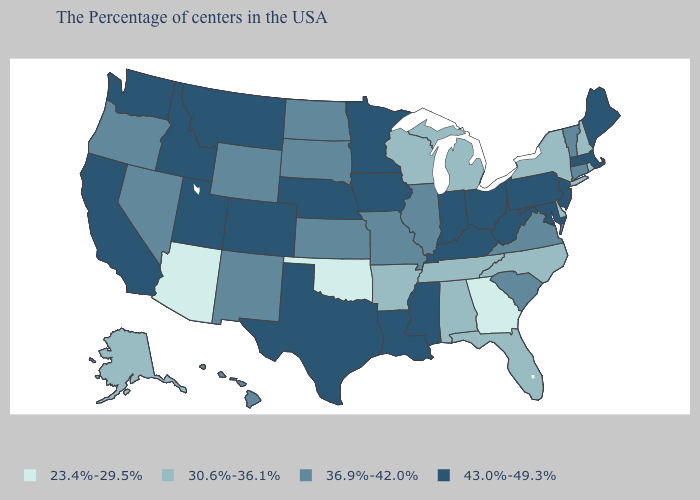Does New Mexico have the highest value in the West?
Short answer required. No. What is the value of New York?
Answer briefly. 30.6%-36.1%. What is the value of Delaware?
Write a very short answer. 30.6%-36.1%. Name the states that have a value in the range 23.4%-29.5%?
Give a very brief answer. Georgia, Oklahoma, Arizona. What is the highest value in the South ?
Give a very brief answer. 43.0%-49.3%. Name the states that have a value in the range 23.4%-29.5%?
Short answer required. Georgia, Oklahoma, Arizona. What is the value of Colorado?
Give a very brief answer. 43.0%-49.3%. What is the value of Kentucky?
Concise answer only. 43.0%-49.3%. How many symbols are there in the legend?
Write a very short answer. 4. Name the states that have a value in the range 23.4%-29.5%?
Be succinct. Georgia, Oklahoma, Arizona. What is the highest value in the South ?
Answer briefly. 43.0%-49.3%. What is the value of South Carolina?
Concise answer only. 36.9%-42.0%. What is the value of Nebraska?
Short answer required. 43.0%-49.3%. Does North Dakota have the highest value in the USA?
Short answer required. No. Which states have the lowest value in the USA?
Keep it brief. Georgia, Oklahoma, Arizona. 